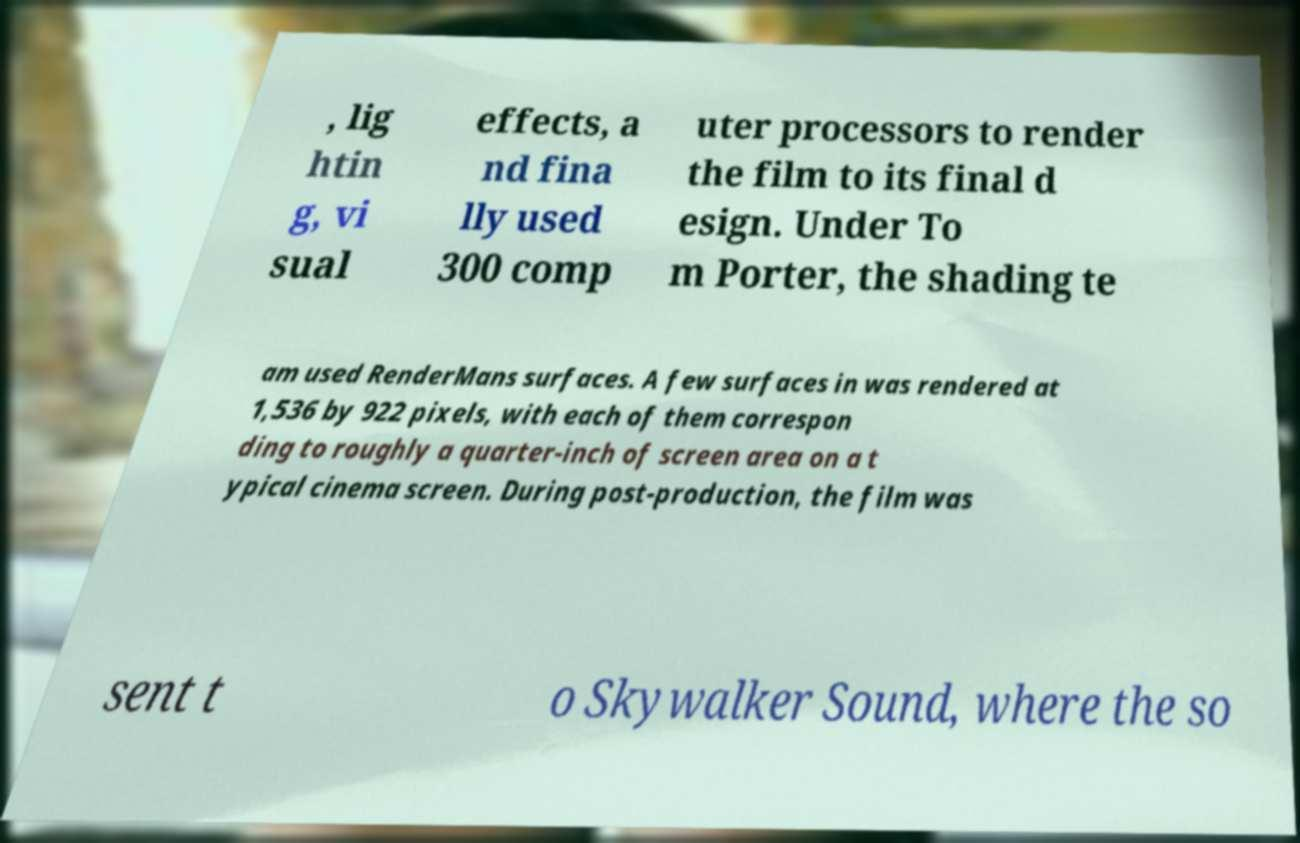Can you read and provide the text displayed in the image?This photo seems to have some interesting text. Can you extract and type it out for me? , lig htin g, vi sual effects, a nd fina lly used 300 comp uter processors to render the film to its final d esign. Under To m Porter, the shading te am used RenderMans surfaces. A few surfaces in was rendered at 1,536 by 922 pixels, with each of them correspon ding to roughly a quarter-inch of screen area on a t ypical cinema screen. During post-production, the film was sent t o Skywalker Sound, where the so 